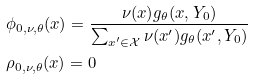Convert formula to latex. <formula><loc_0><loc_0><loc_500><loc_500>& \phi _ { 0 , \nu , \theta } ( x ) = \frac { \nu ( x ) g _ { \theta } ( x , Y _ { 0 } ) } { \sum _ { x ^ { \prime } \in \mathcal { X } } \nu ( x ^ { \prime } ) g _ { \theta } ( x ^ { \prime } , Y _ { 0 } ) } \\ & \rho _ { 0 , \nu , \theta } ( x ) = 0</formula> 